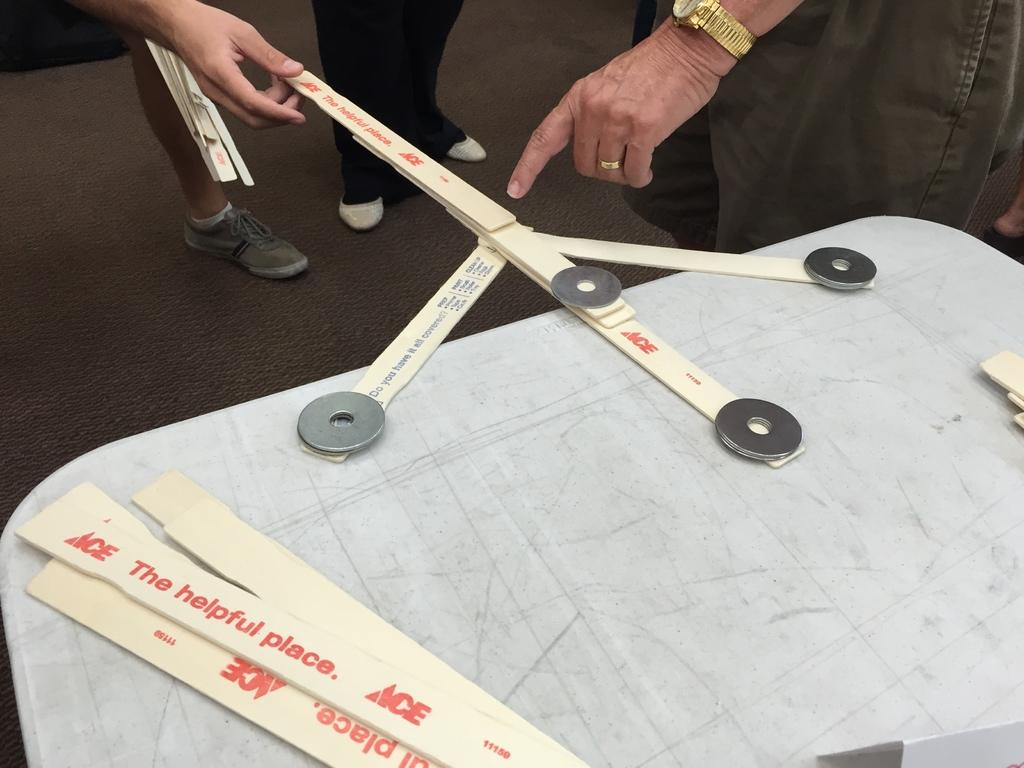What color is the table in the image? The table in the image is white. What can be found on the table? There are objects on the table. Can you describe what is visible at the bottom of the image? People's legs are visible in the image. What type of jewelry is worn by one of the people in the image? A person is wearing a ring. What time-telling device is visible on one of the people's wrists? A person is wearing a wristwatch. How does the jellyfish react to the earthquake in the image? There are no jellyfish or earthquakes present in the image. What type of bird is perched on the person's shoulder in the image? There are no birds, specifically wrens, present in the image. 